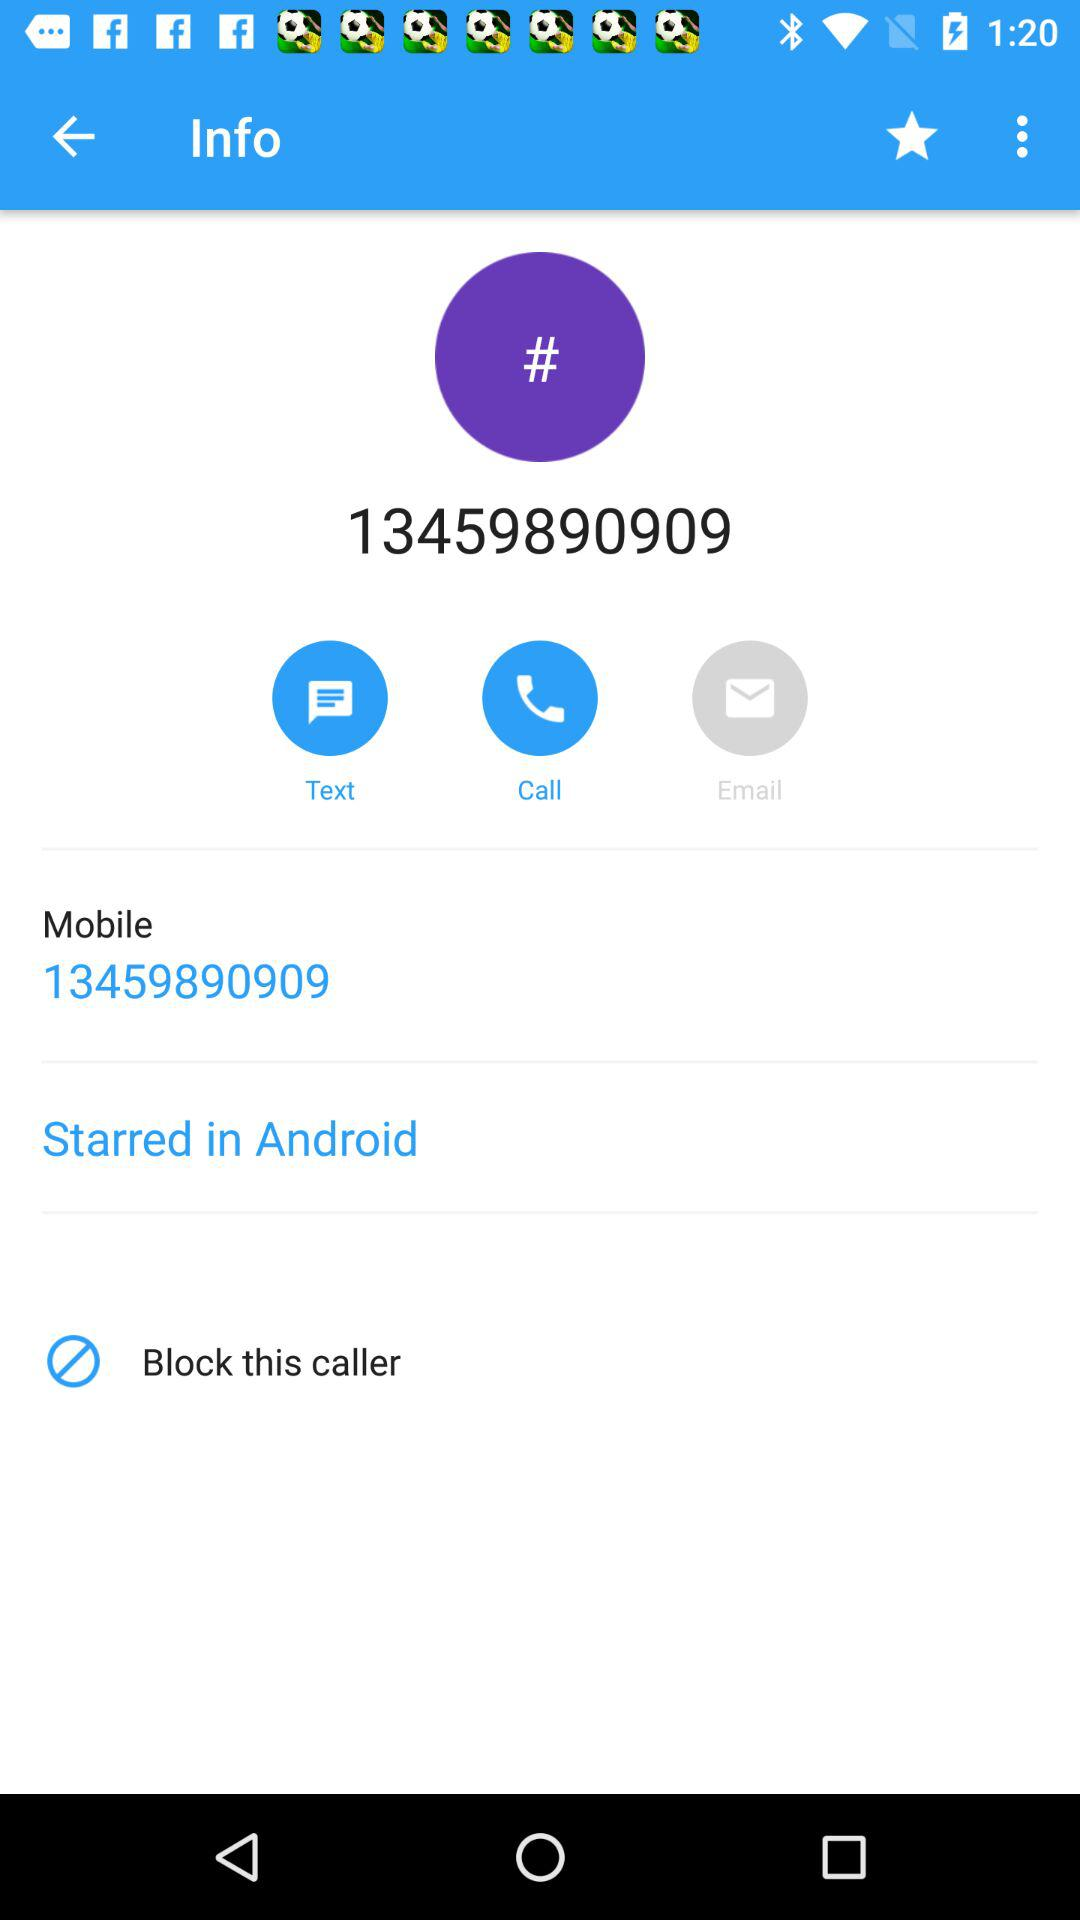Which number is blocked?
When the provided information is insufficient, respond with <no answer>. <no answer> 